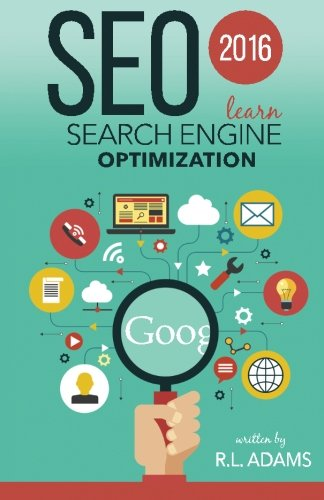Is this a life story book? No, this book is not a life story; it is an educational guide that focuses on teaching SEO techniques for enhancing online visibility and effectiveness. 